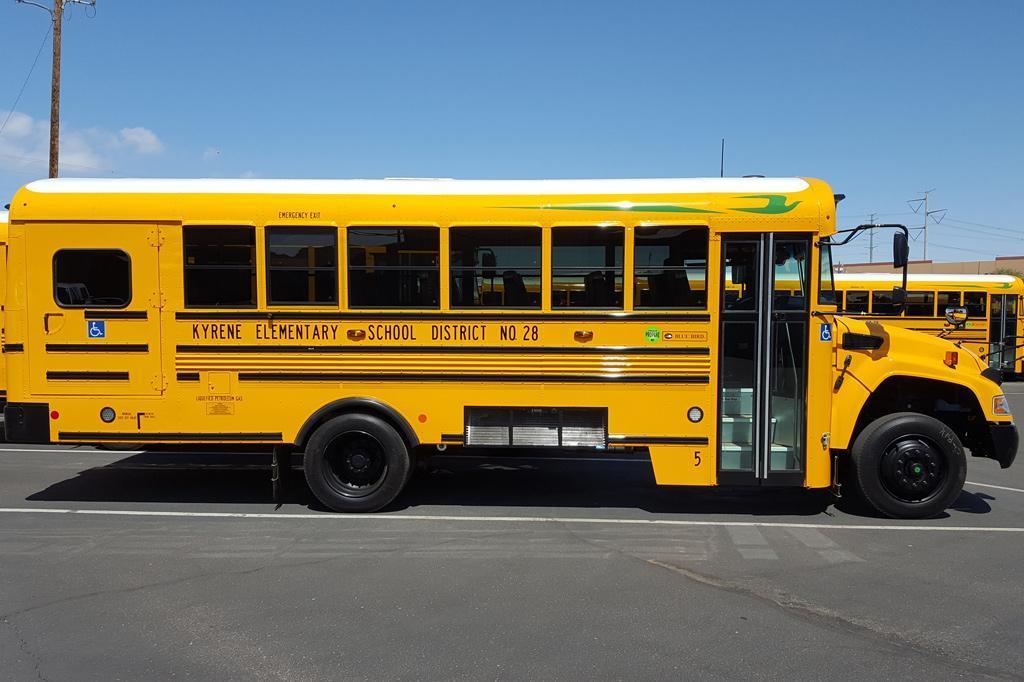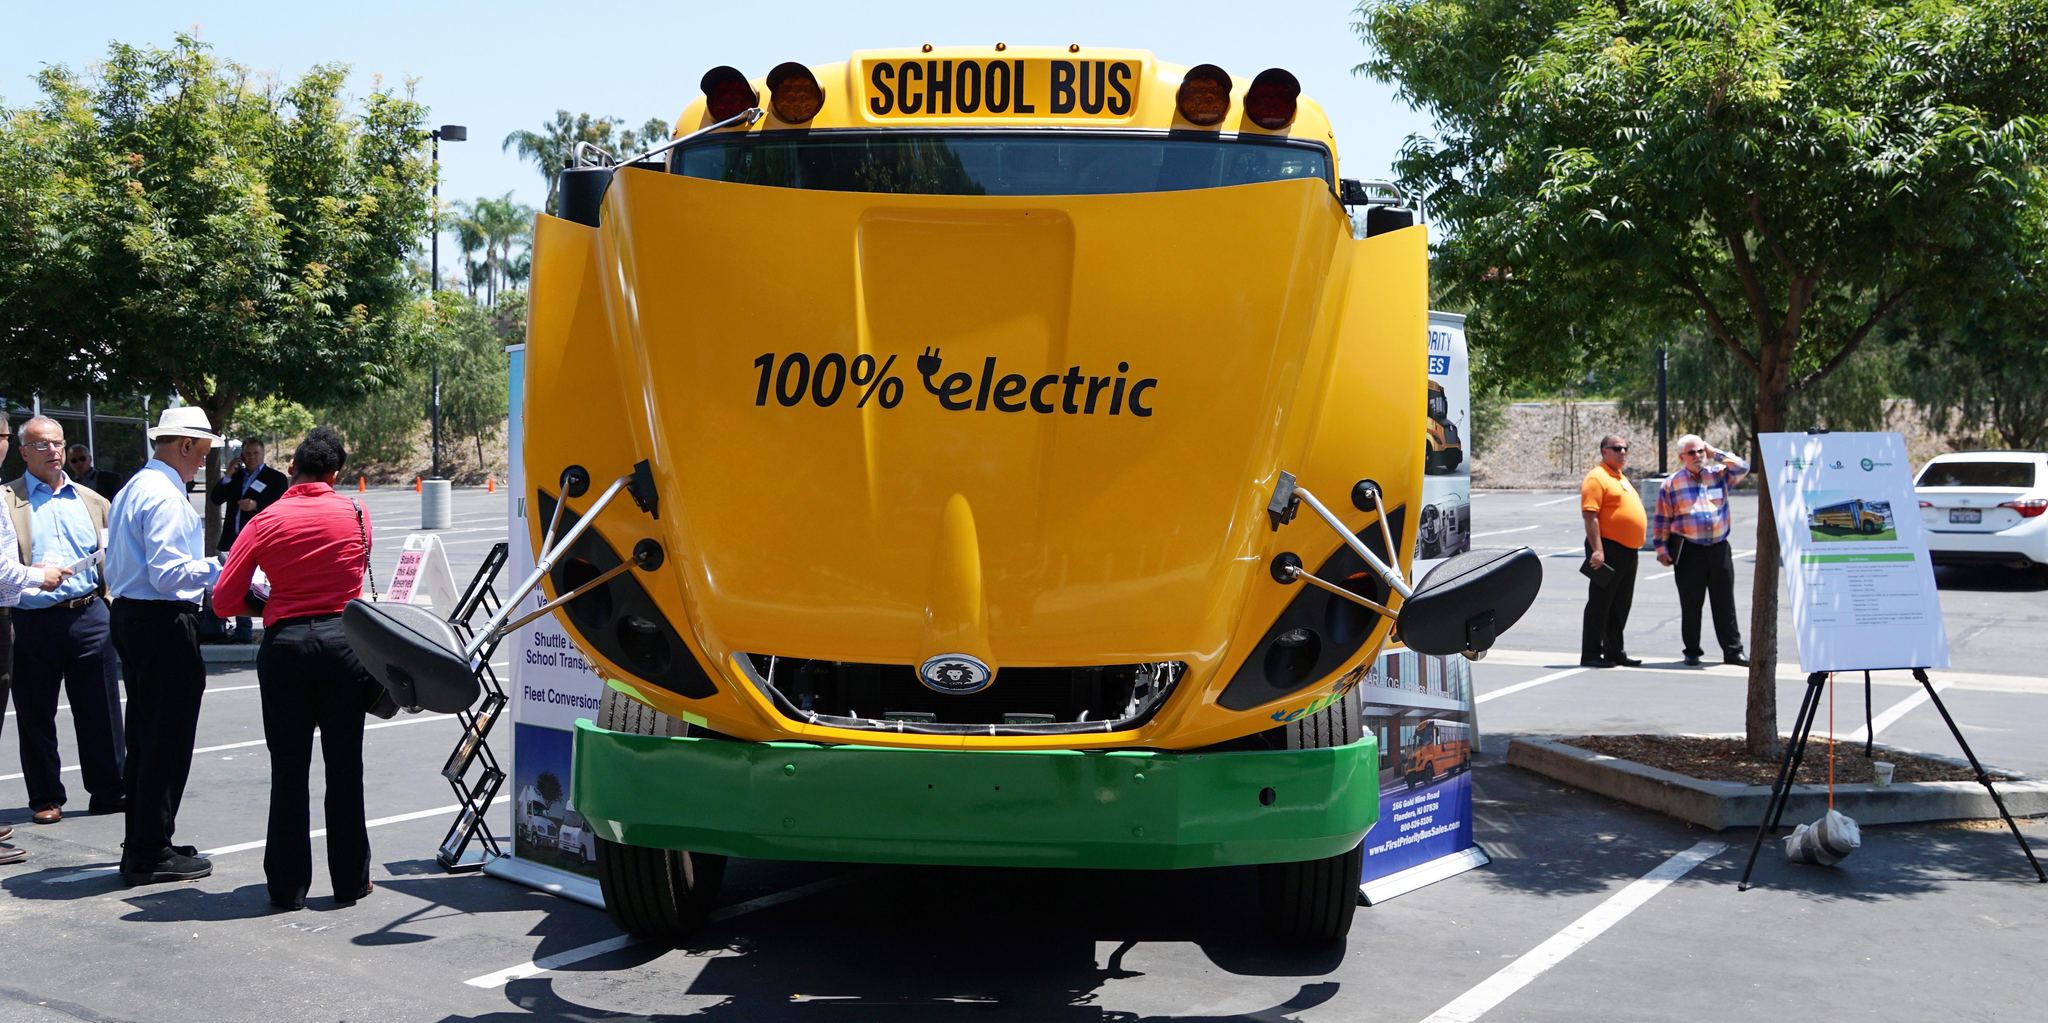The first image is the image on the left, the second image is the image on the right. Examine the images to the left and right. Is the description "The left image features one flat-fronted bus parked at an angle in a parking lot, and the right image features a row of parked buses forming a diagonal line." accurate? Answer yes or no. No. 